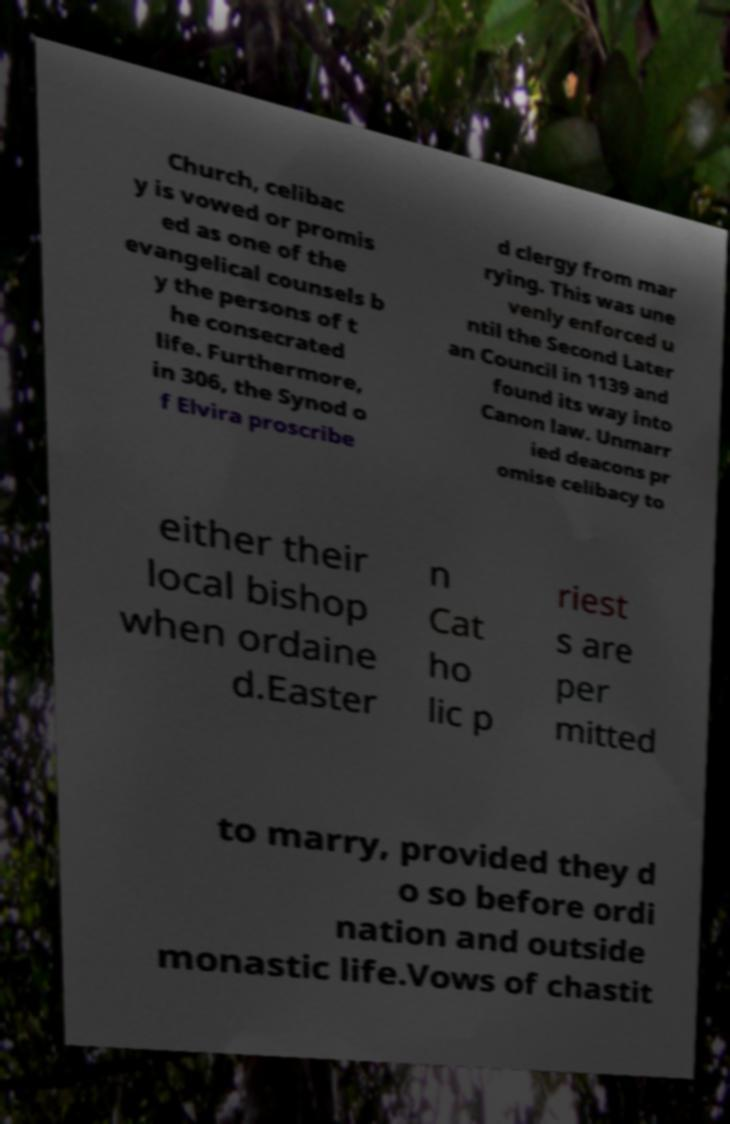What messages or text are displayed in this image? I need them in a readable, typed format. Church, celibac y is vowed or promis ed as one of the evangelical counsels b y the persons of t he consecrated life. Furthermore, in 306, the Synod o f Elvira proscribe d clergy from mar rying. This was une venly enforced u ntil the Second Later an Council in 1139 and found its way into Canon law. Unmarr ied deacons pr omise celibacy to either their local bishop when ordaine d.Easter n Cat ho lic p riest s are per mitted to marry, provided they d o so before ordi nation and outside monastic life.Vows of chastit 